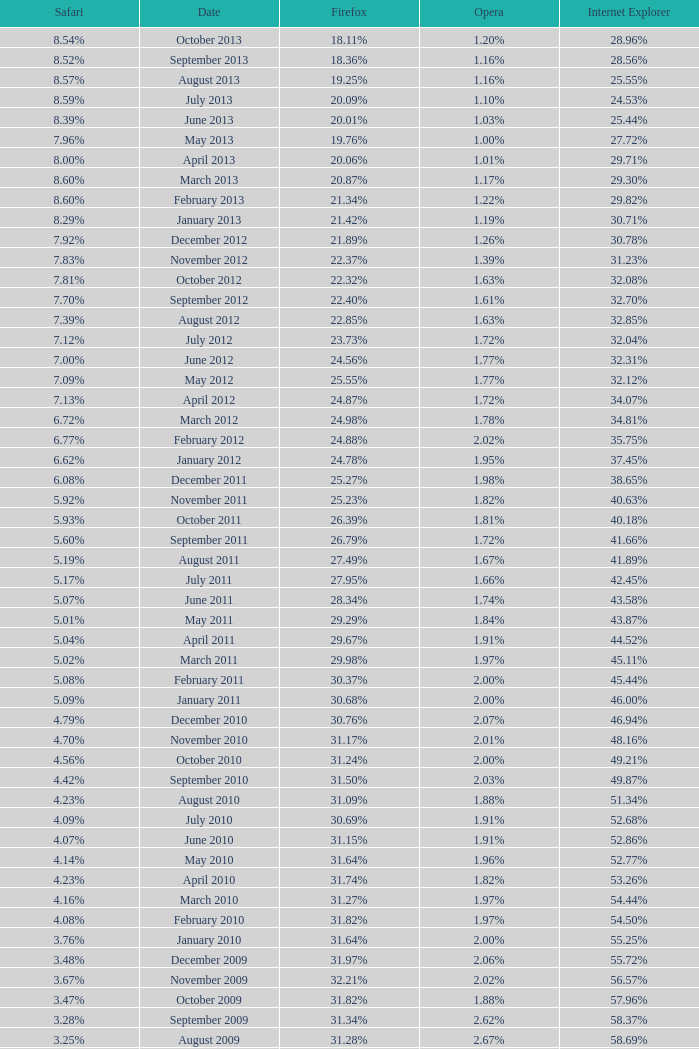What percentage of browsers were using Internet Explorer during the period in which 27.85% were using Firefox? 64.43%. 